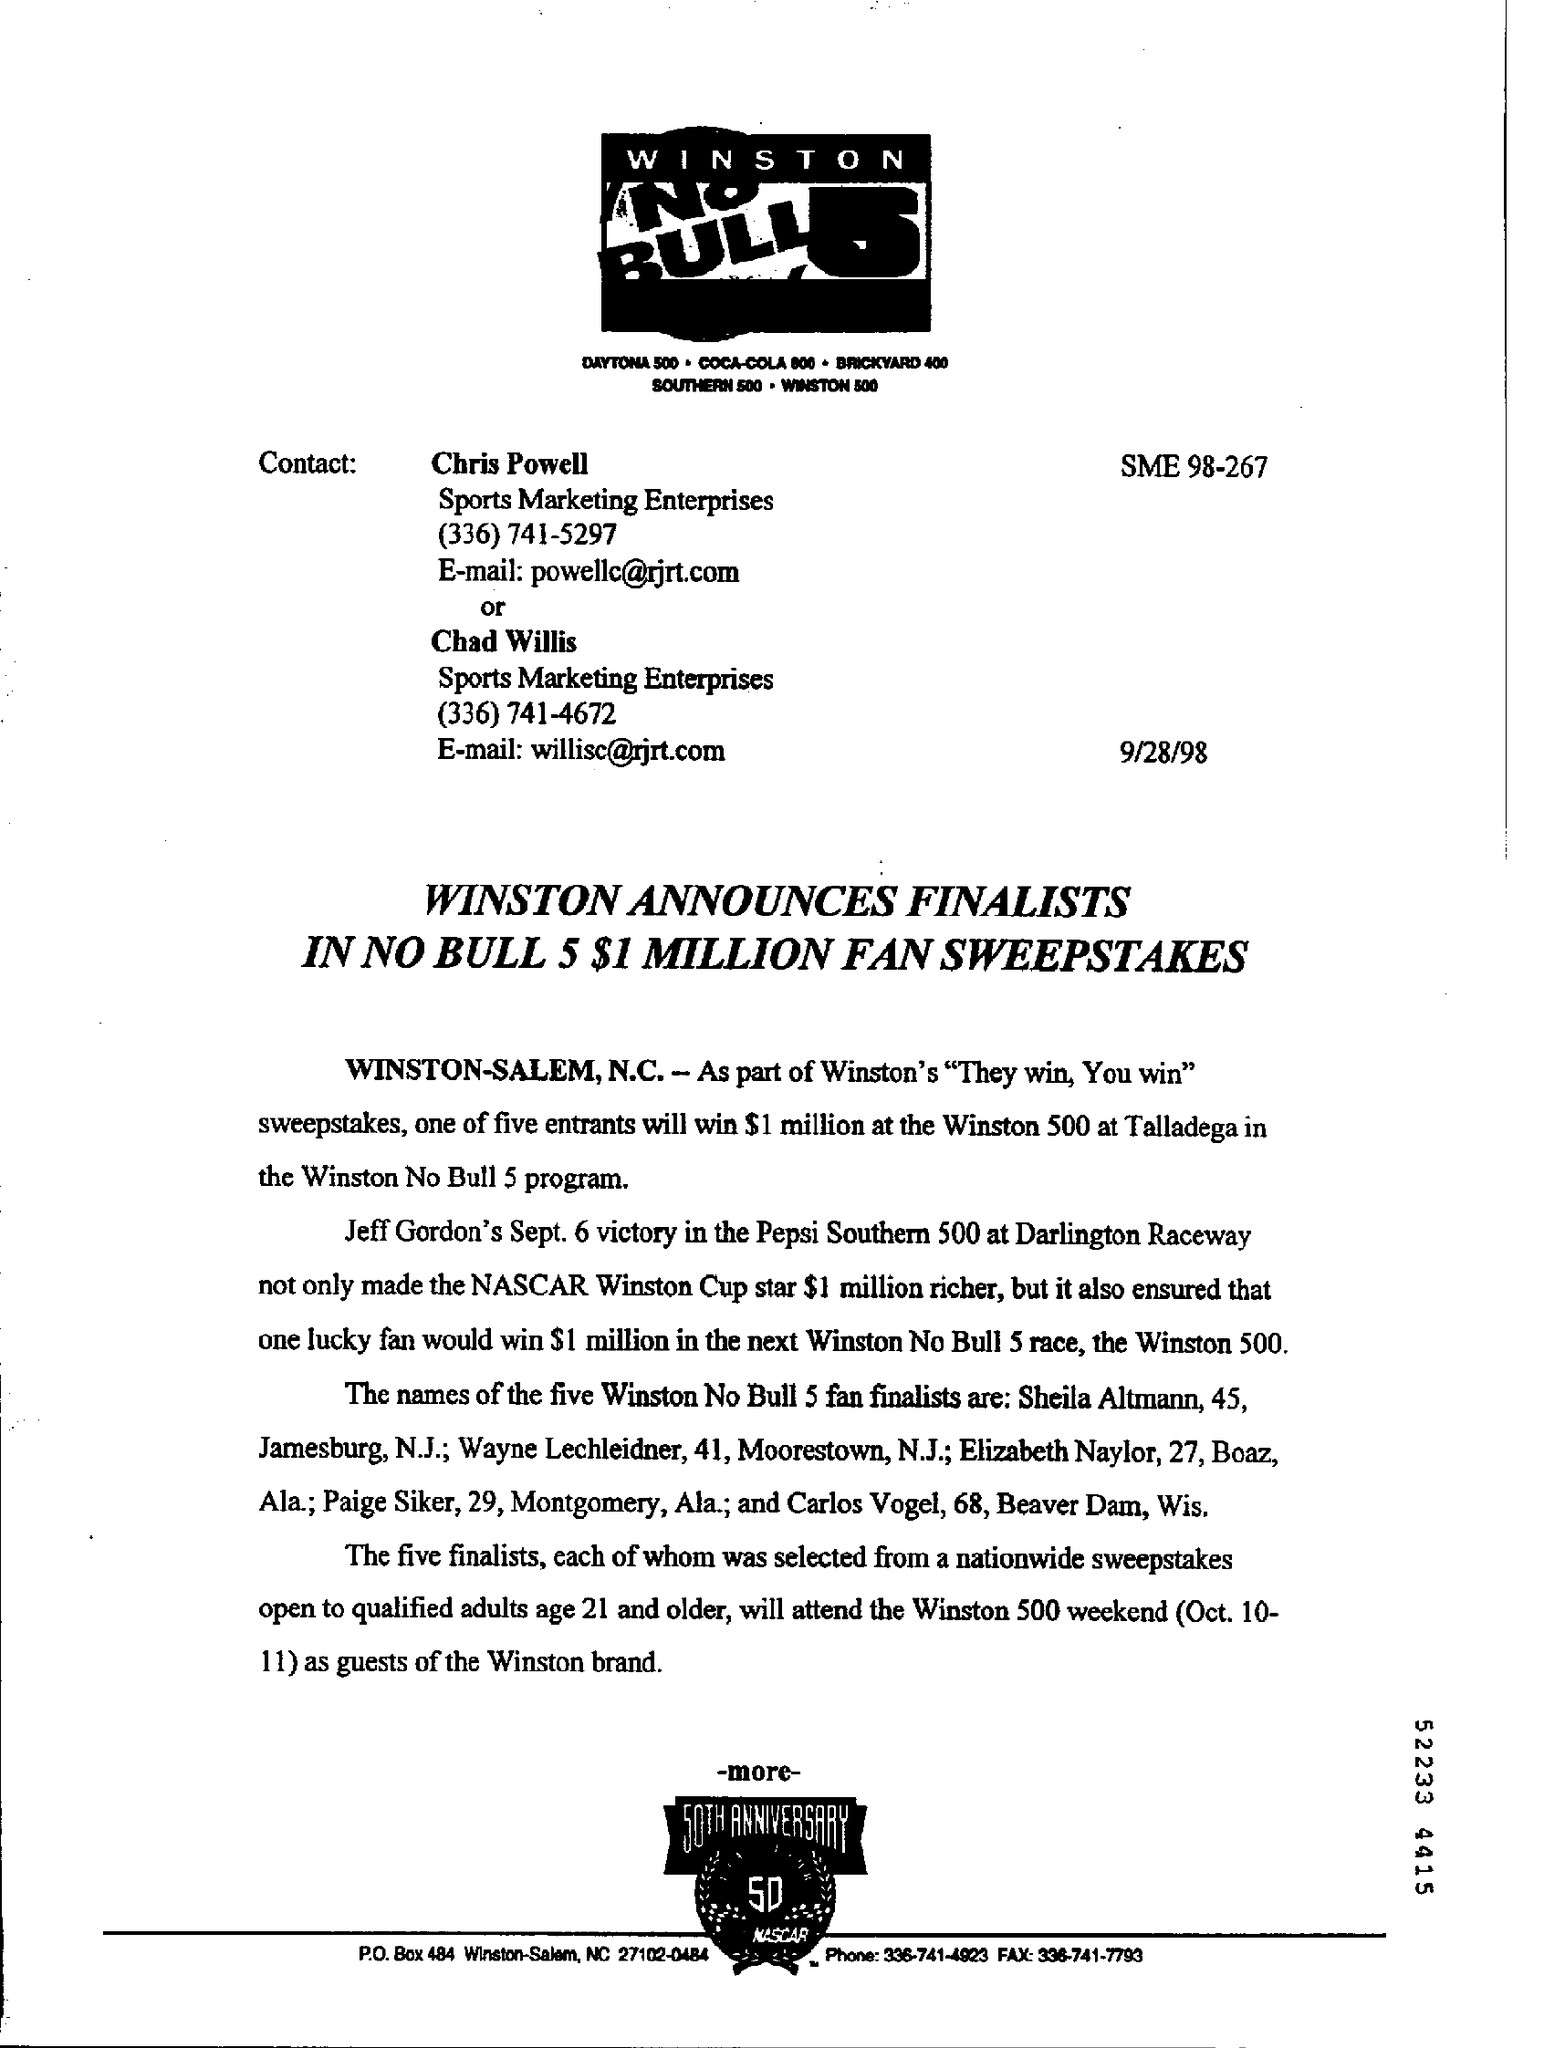What is the date on the document?
Your answer should be very brief. 9/28/98. 